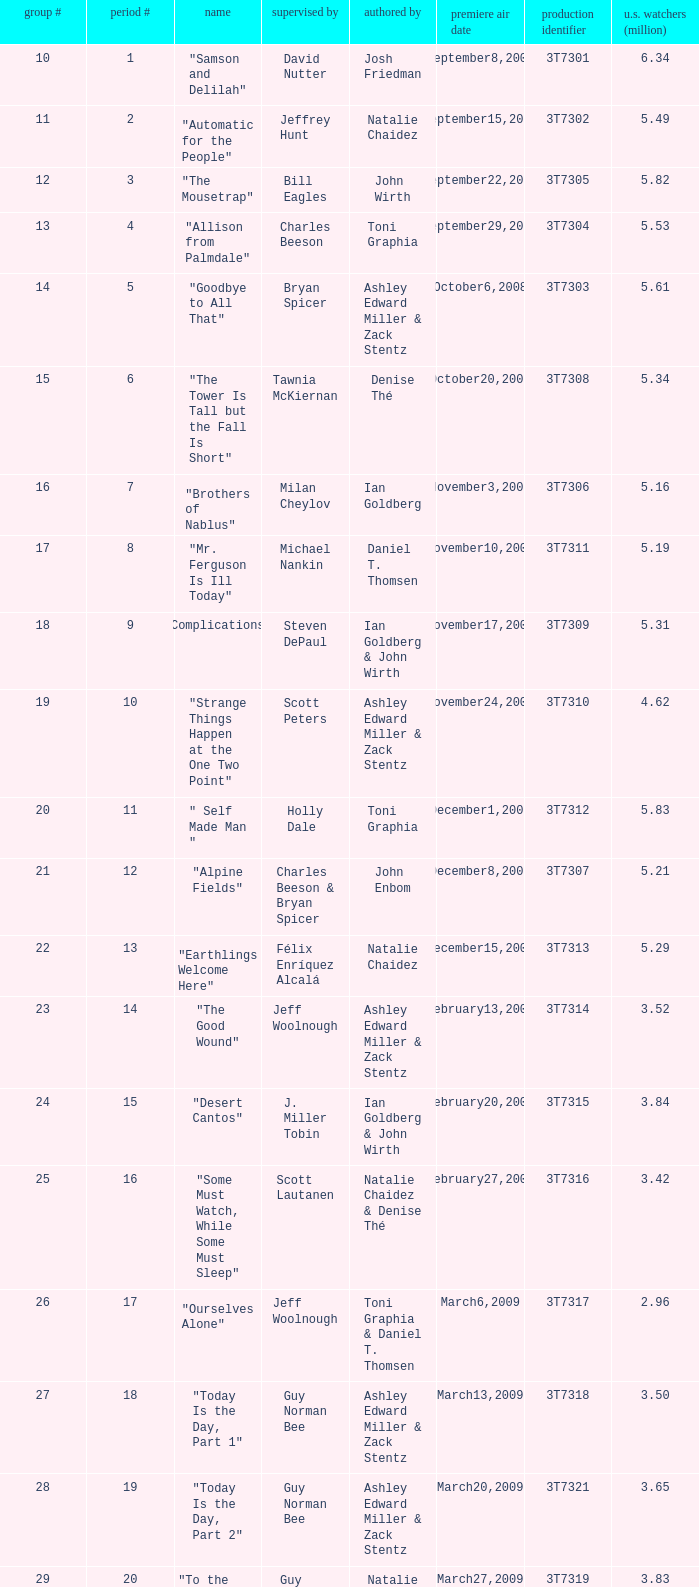Which episode number drew in 3.35 million viewers in the United States? 1.0. 